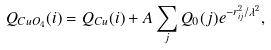Convert formula to latex. <formula><loc_0><loc_0><loc_500><loc_500>Q _ { C u O _ { 4 } } ( i ) = Q _ { C u } ( i ) + A \sum _ { j } Q _ { 0 } ( j ) e ^ { - r _ { i j } ^ { 2 } / \lambda ^ { 2 } } ,</formula> 